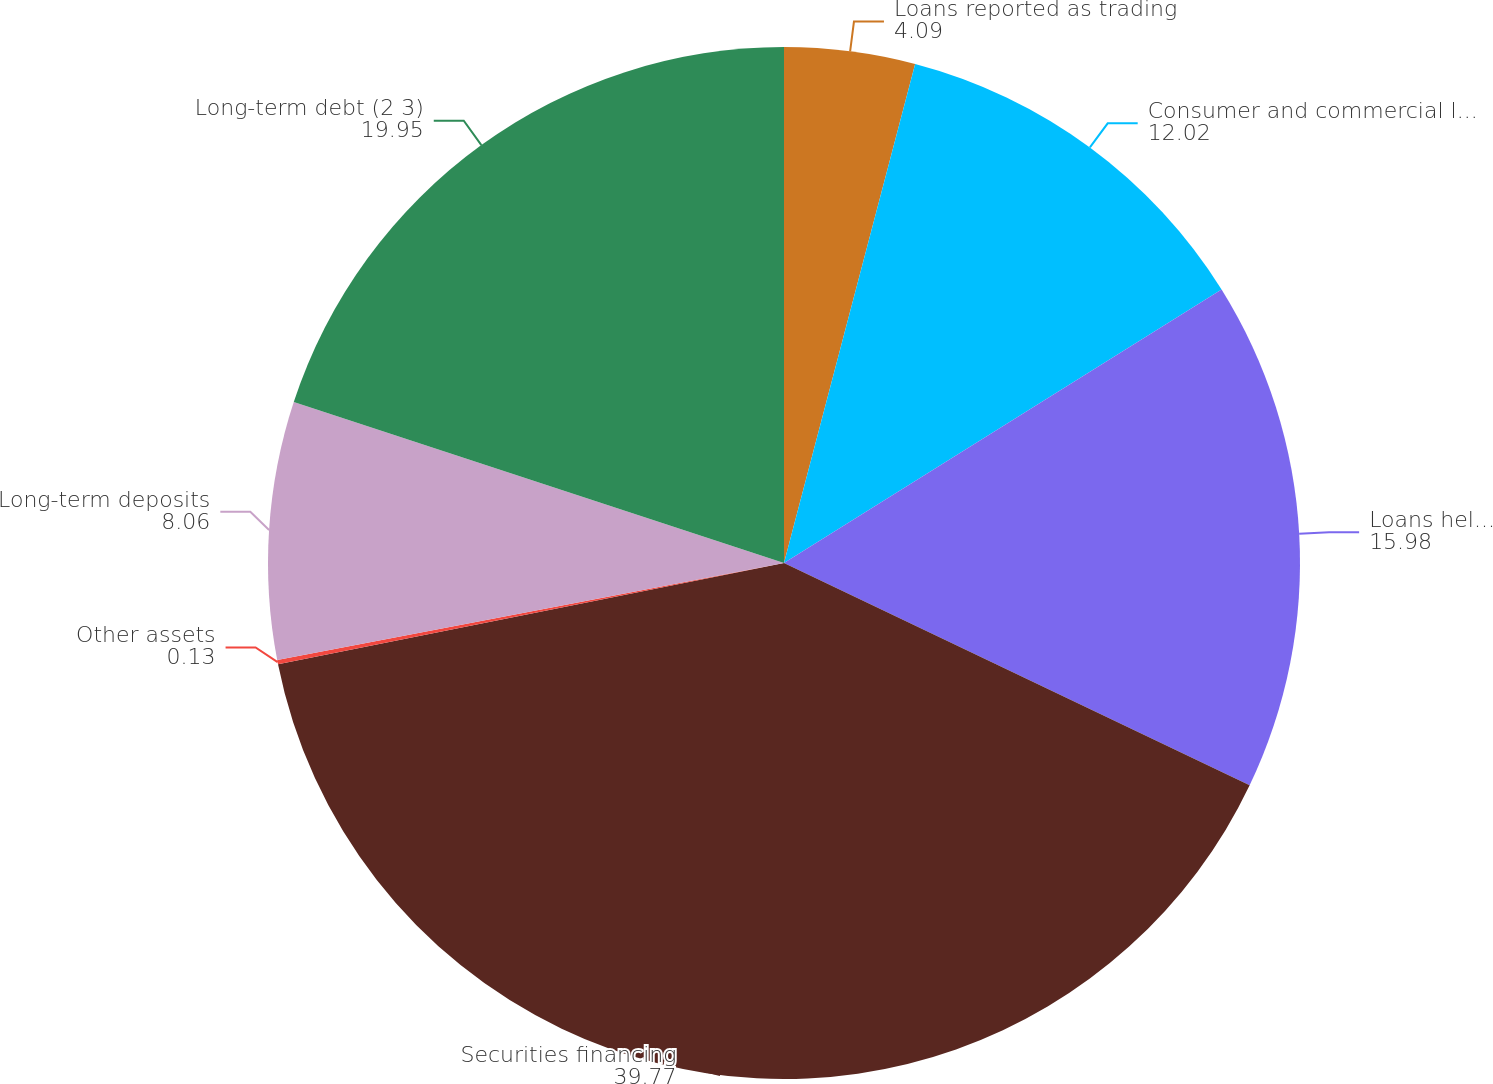Convert chart. <chart><loc_0><loc_0><loc_500><loc_500><pie_chart><fcel>Loans reported as trading<fcel>Consumer and commercial loans<fcel>Loans held-for-sale<fcel>Securities financing<fcel>Other assets<fcel>Long-term deposits<fcel>Long-term debt (2 3)<nl><fcel>4.09%<fcel>12.02%<fcel>15.98%<fcel>39.77%<fcel>0.13%<fcel>8.06%<fcel>19.95%<nl></chart> 